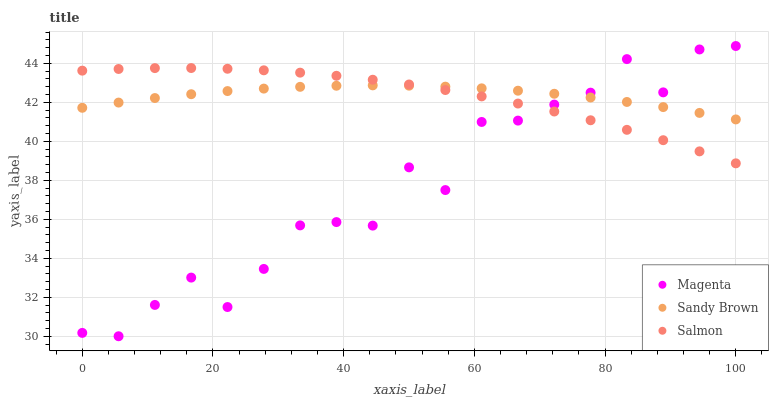Does Magenta have the minimum area under the curve?
Answer yes or no. Yes. Does Sandy Brown have the maximum area under the curve?
Answer yes or no. Yes. Does Sandy Brown have the minimum area under the curve?
Answer yes or no. No. Does Magenta have the maximum area under the curve?
Answer yes or no. No. Is Sandy Brown the smoothest?
Answer yes or no. Yes. Is Magenta the roughest?
Answer yes or no. Yes. Is Magenta the smoothest?
Answer yes or no. No. Is Sandy Brown the roughest?
Answer yes or no. No. Does Magenta have the lowest value?
Answer yes or no. Yes. Does Sandy Brown have the lowest value?
Answer yes or no. No. Does Magenta have the highest value?
Answer yes or no. Yes. Does Sandy Brown have the highest value?
Answer yes or no. No. Does Magenta intersect Salmon?
Answer yes or no. Yes. Is Magenta less than Salmon?
Answer yes or no. No. Is Magenta greater than Salmon?
Answer yes or no. No. 